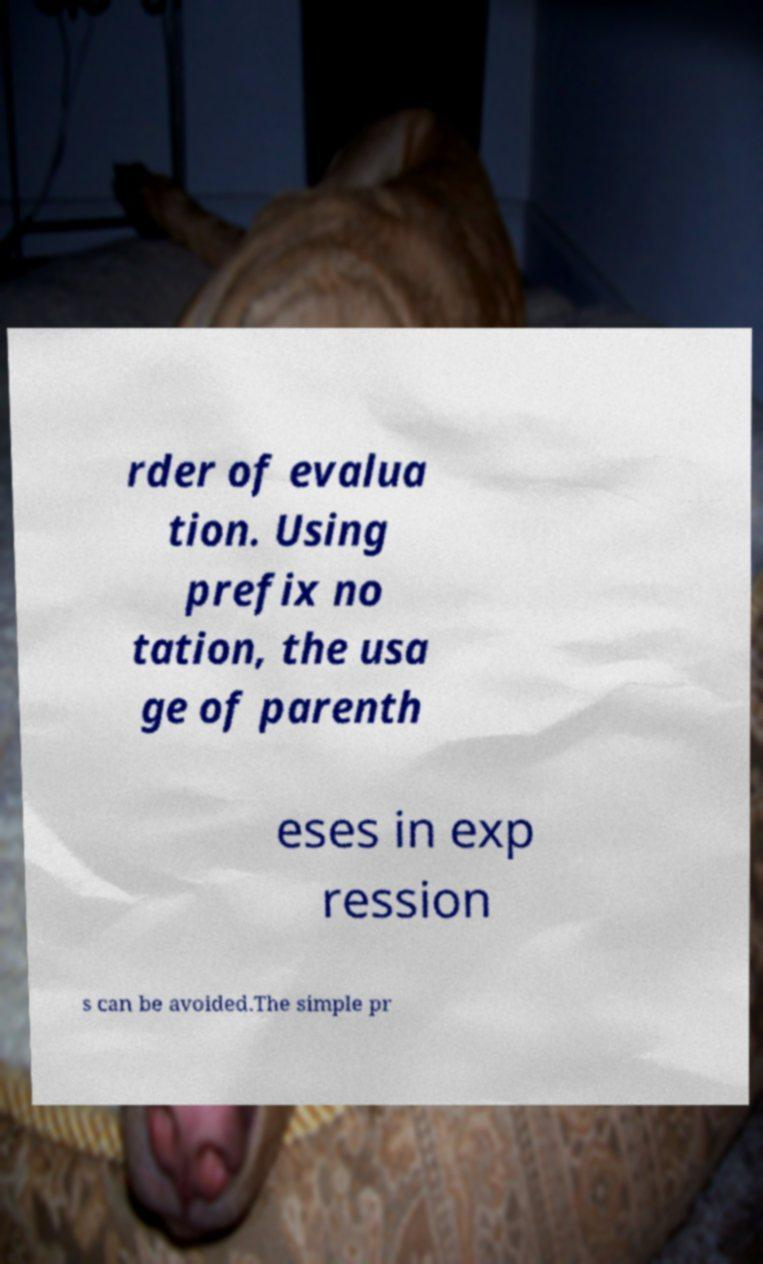What messages or text are displayed in this image? I need them in a readable, typed format. rder of evalua tion. Using prefix no tation, the usa ge of parenth eses in exp ression s can be avoided.The simple pr 